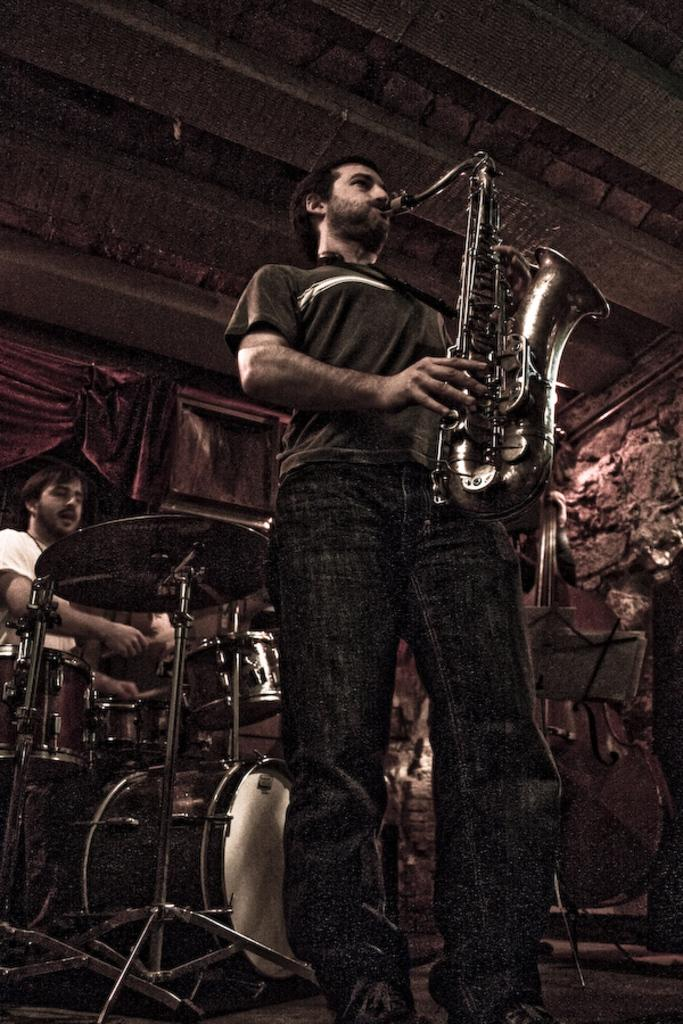What is the man in the image wearing? The man in the image is wearing a t-shirt and pants. What is the man doing in the image? The man is standing and playing a saxophone. Can you describe the other man in the image? The second man is wearing a white t-shirt and playing drums. What is visible in the background of the image? There is a curtain visible in the image. What type of waves can be seen in the image? There are no waves present in the image; it features two men playing musical instruments. What type of exchange is happening between the two men in the image? There is no exchange happening between the two men in the image; they are simply playing their respective instruments. 